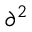<formula> <loc_0><loc_0><loc_500><loc_500>{ \partial } ^ { 2 }</formula> 